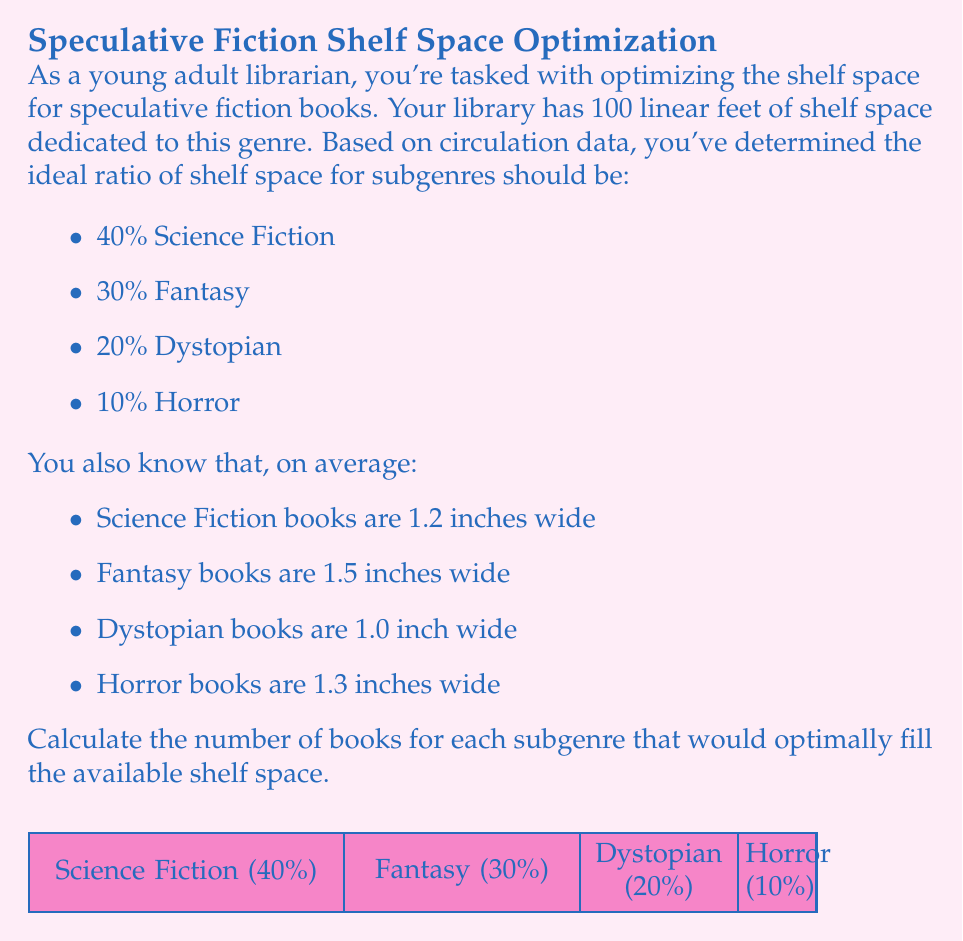Can you solve this math problem? Let's approach this step-by-step:

1) First, calculate the space allocated to each subgenre:
   - Science Fiction: $40\% \times 100\text{ ft} = 40\text{ ft}$
   - Fantasy: $30\% \times 100\text{ ft} = 30\text{ ft}$
   - Dystopian: $20\% \times 100\text{ ft} = 20\text{ ft}$
   - Horror: $10\% \times 100\text{ ft} = 10\text{ ft}$

2) Convert feet to inches:
   - Science Fiction: $40\text{ ft} \times 12\text{ in/ft} = 480\text{ in}$
   - Fantasy: $30\text{ ft} \times 12\text{ in/ft} = 360\text{ in}$
   - Dystopian: $20\text{ ft} \times 12\text{ in/ft} = 240\text{ in}$
   - Horror: $10\text{ ft} \times 12\text{ in/ft} = 120\text{ in}$

3) Calculate the number of books for each subgenre:
   - Science Fiction: $480\text{ in} \div 1.2\text{ in/book} = 400\text{ books}$
   - Fantasy: $360\text{ in} \div 1.5\text{ in/book} = 240\text{ books}$
   - Dystopian: $240\text{ in} \div 1.0\text{ in/book} = 240\text{ books}$
   - Horror: $120\text{ in} \div 1.3\text{ in/book} \approx 92.31\text{ books}$

4) Round down to the nearest whole number for Horror:
   Horror: $92\text{ books}$
Answer: Science Fiction: 400, Fantasy: 240, Dystopian: 240, Horror: 92 